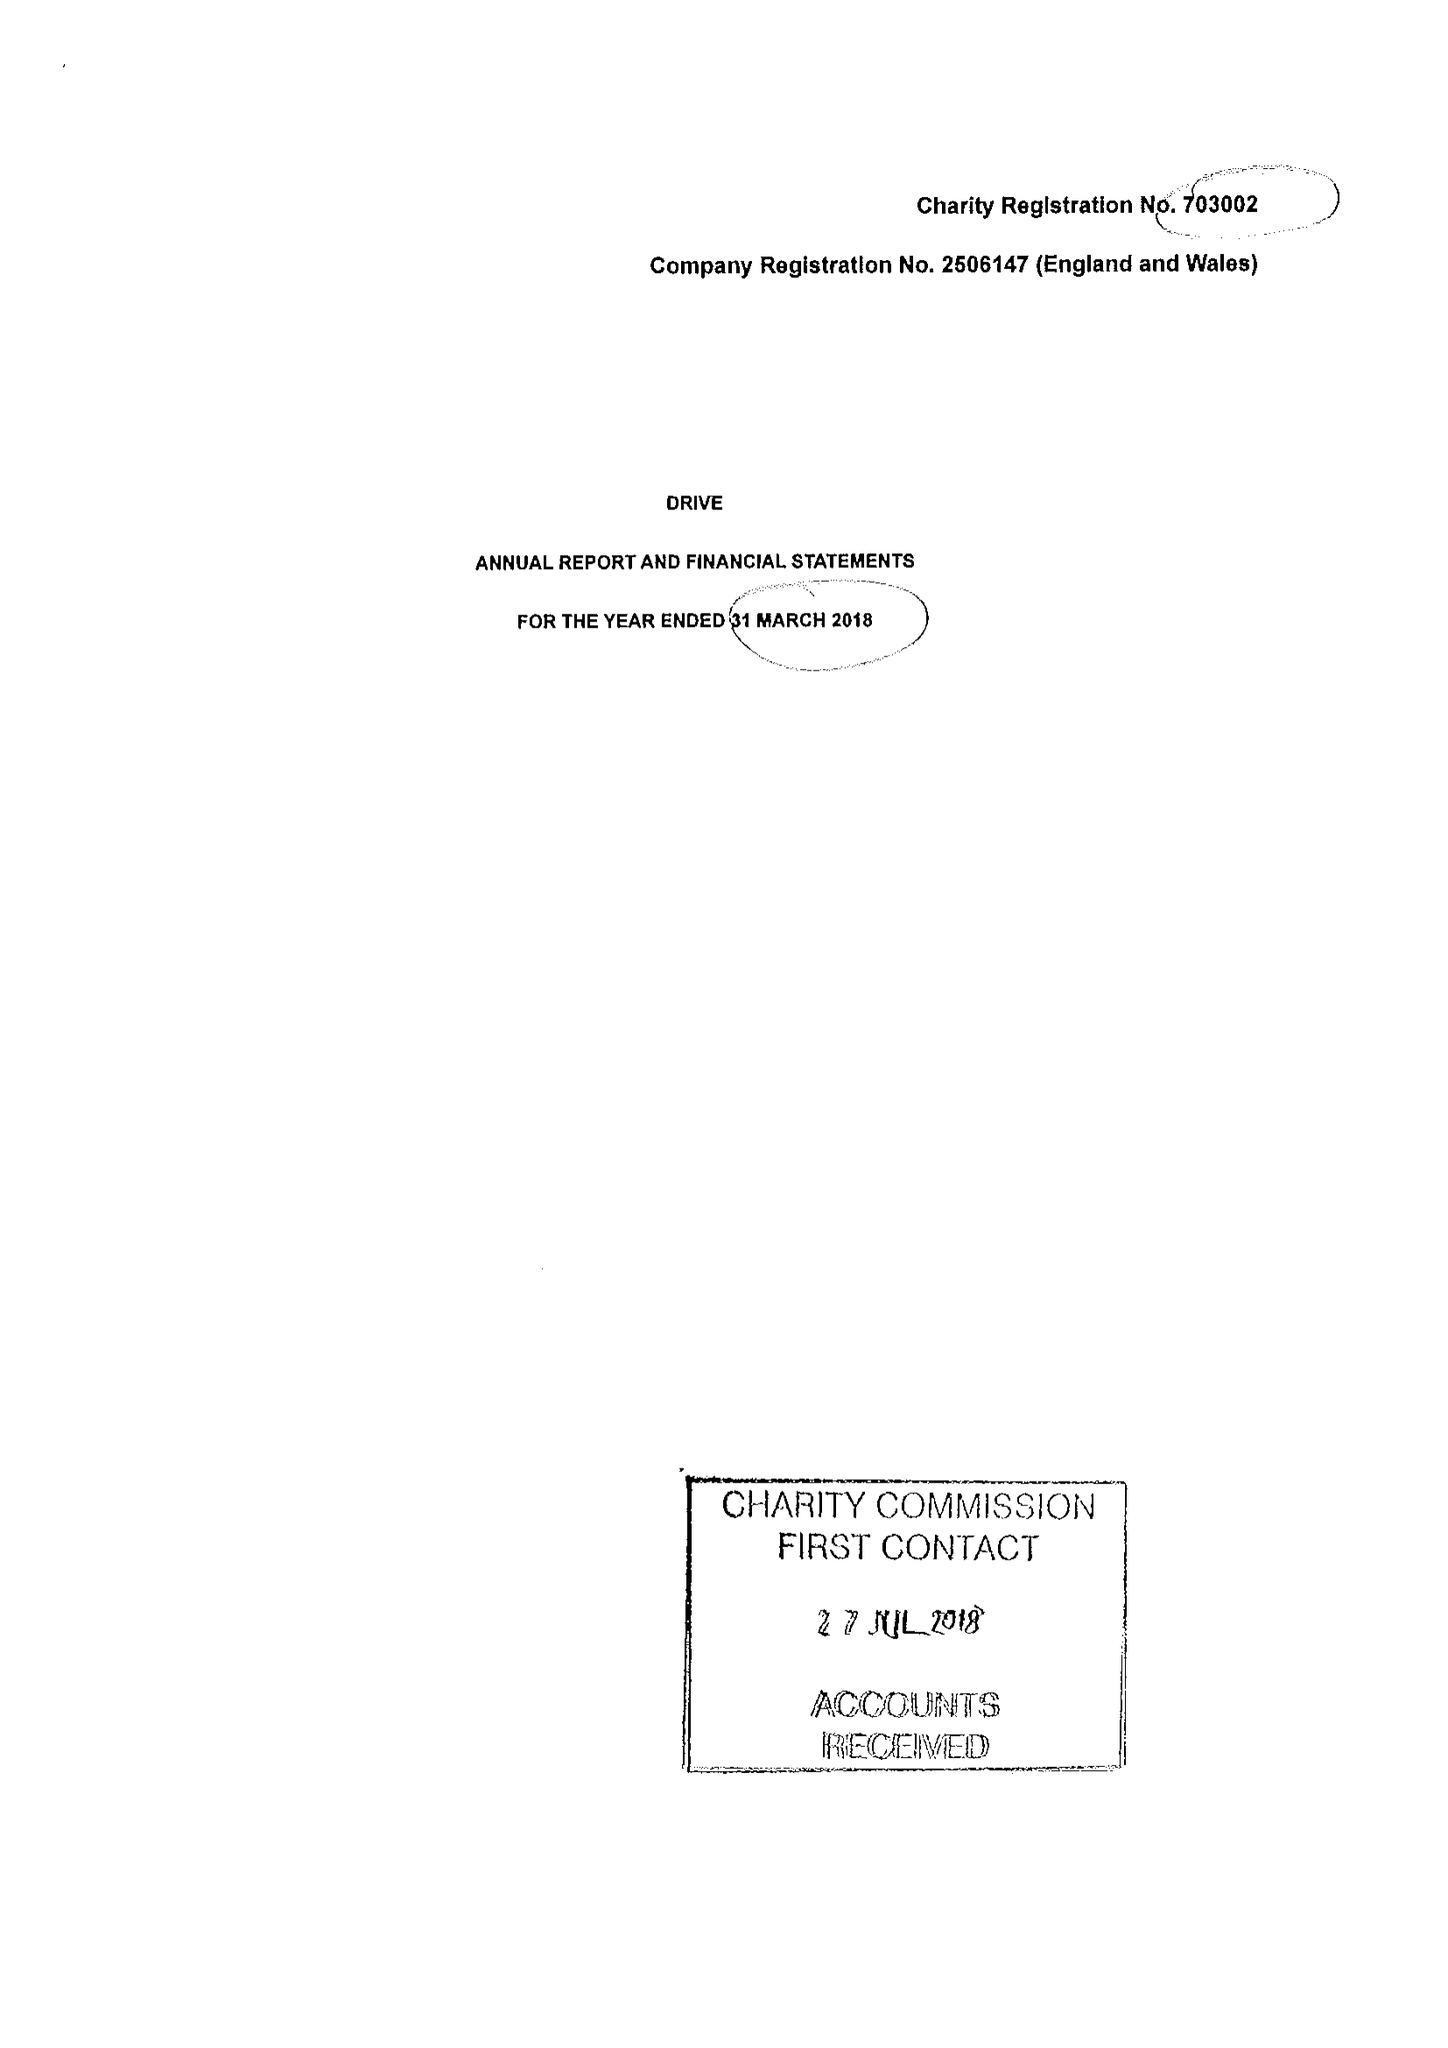What is the value for the address__postcode?
Answer the question using a single word or phrase. CF15 7QQ 